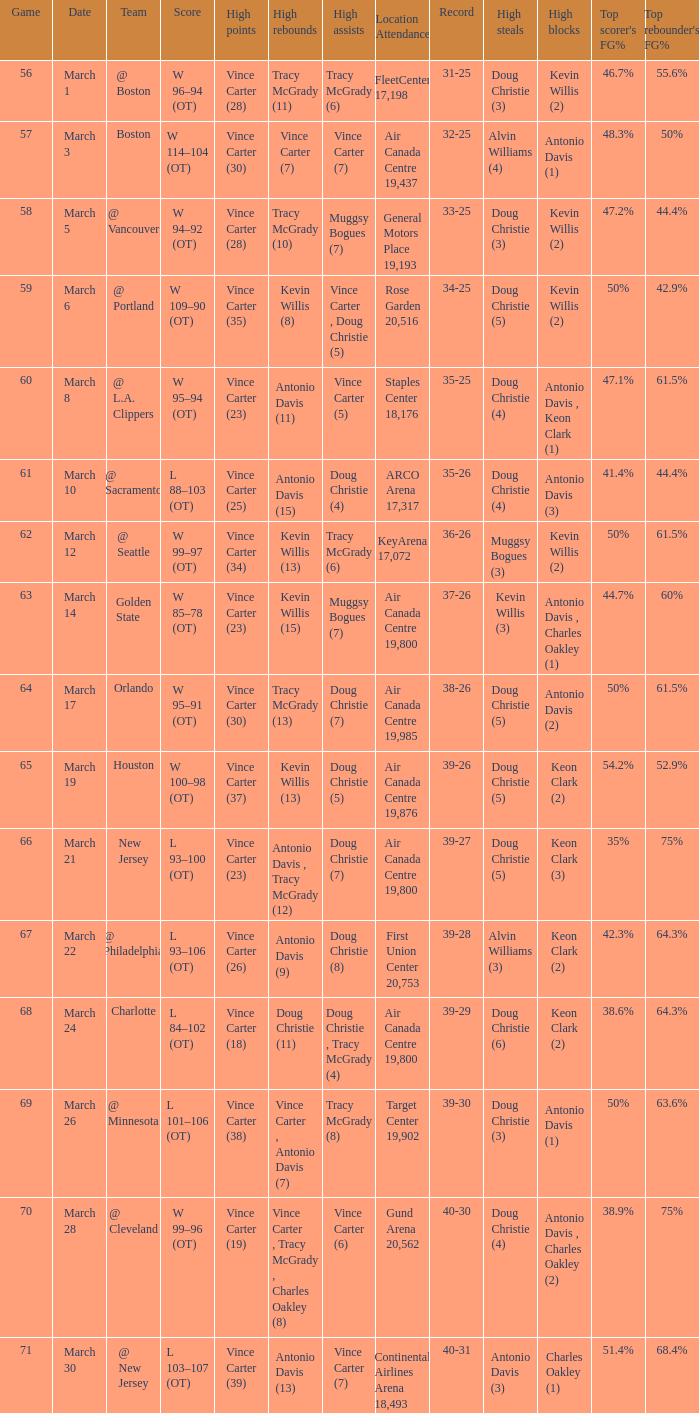What day was the attendance at the staples center 18,176? March 8. 